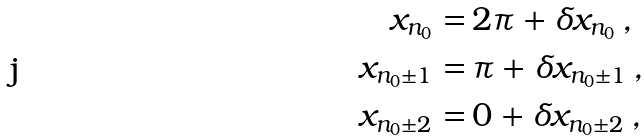Convert formula to latex. <formula><loc_0><loc_0><loc_500><loc_500>x _ { n _ { 0 } } = & \, 2 \pi + \delta x _ { n _ { 0 } } \, , \\ x _ { n _ { 0 } \pm 1 } = & \, \pi + \delta x _ { n _ { 0 } \pm 1 } \, , \\ x _ { n _ { 0 } \pm 2 } = & \, 0 + \delta x _ { n _ { 0 } \pm 2 } \, ,</formula> 